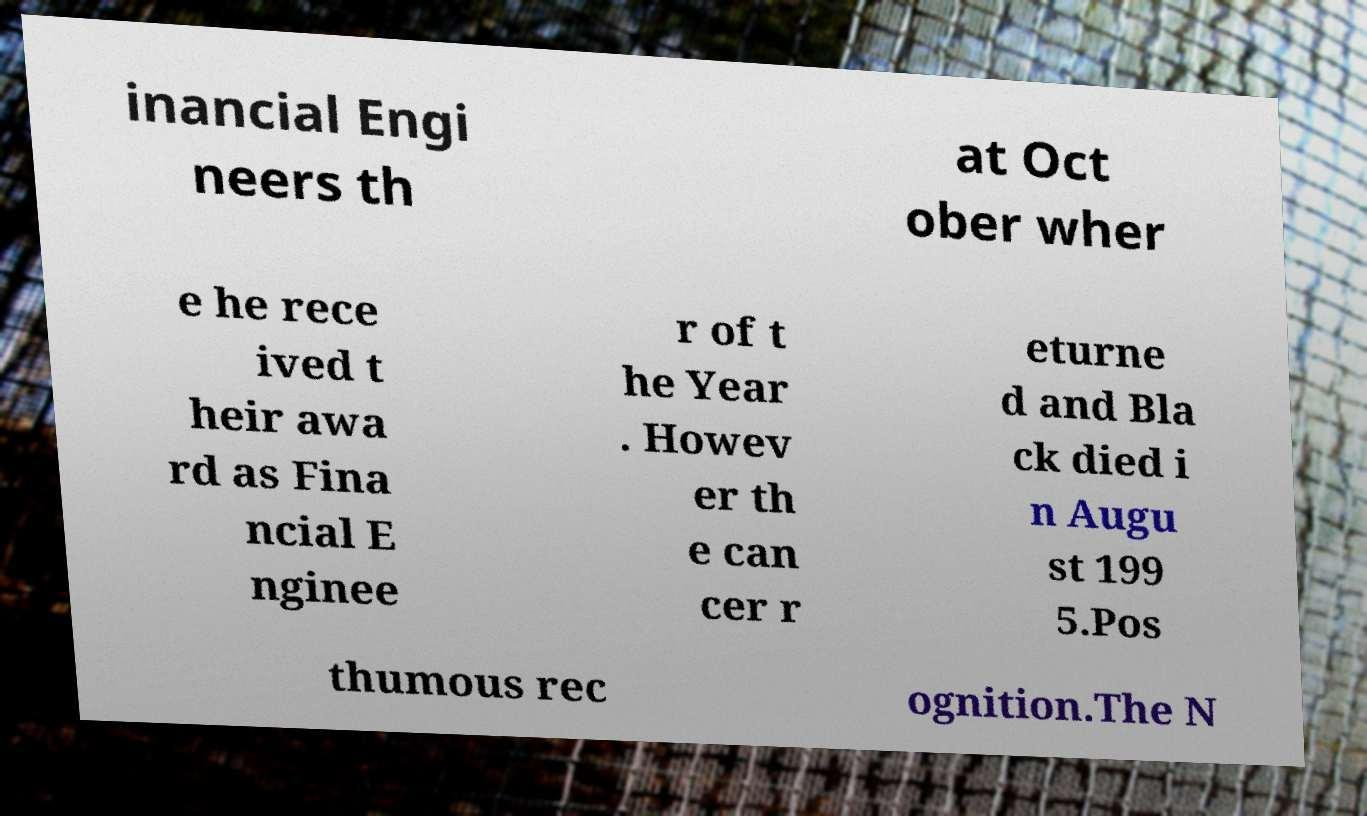Can you read and provide the text displayed in the image?This photo seems to have some interesting text. Can you extract and type it out for me? inancial Engi neers th at Oct ober wher e he rece ived t heir awa rd as Fina ncial E nginee r of t he Year . Howev er th e can cer r eturne d and Bla ck died i n Augu st 199 5.Pos thumous rec ognition.The N 